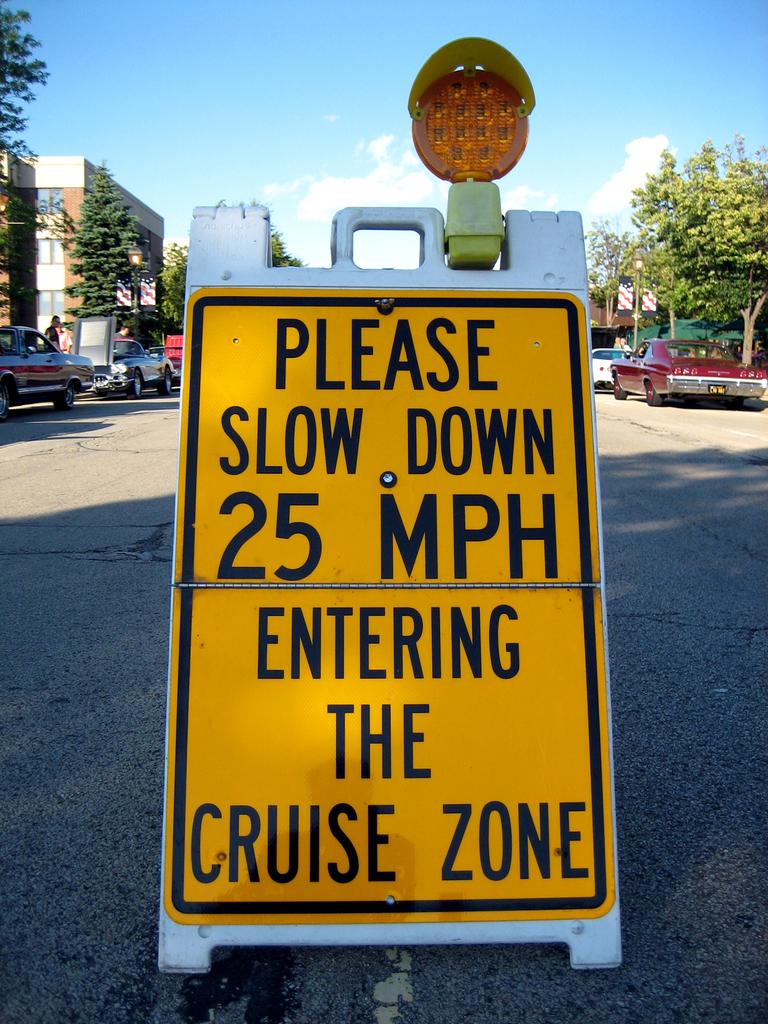Which zone are you entering by driving past the sign?
Provide a succinct answer. Cruise zone. How many mph?
Give a very brief answer. 25. 